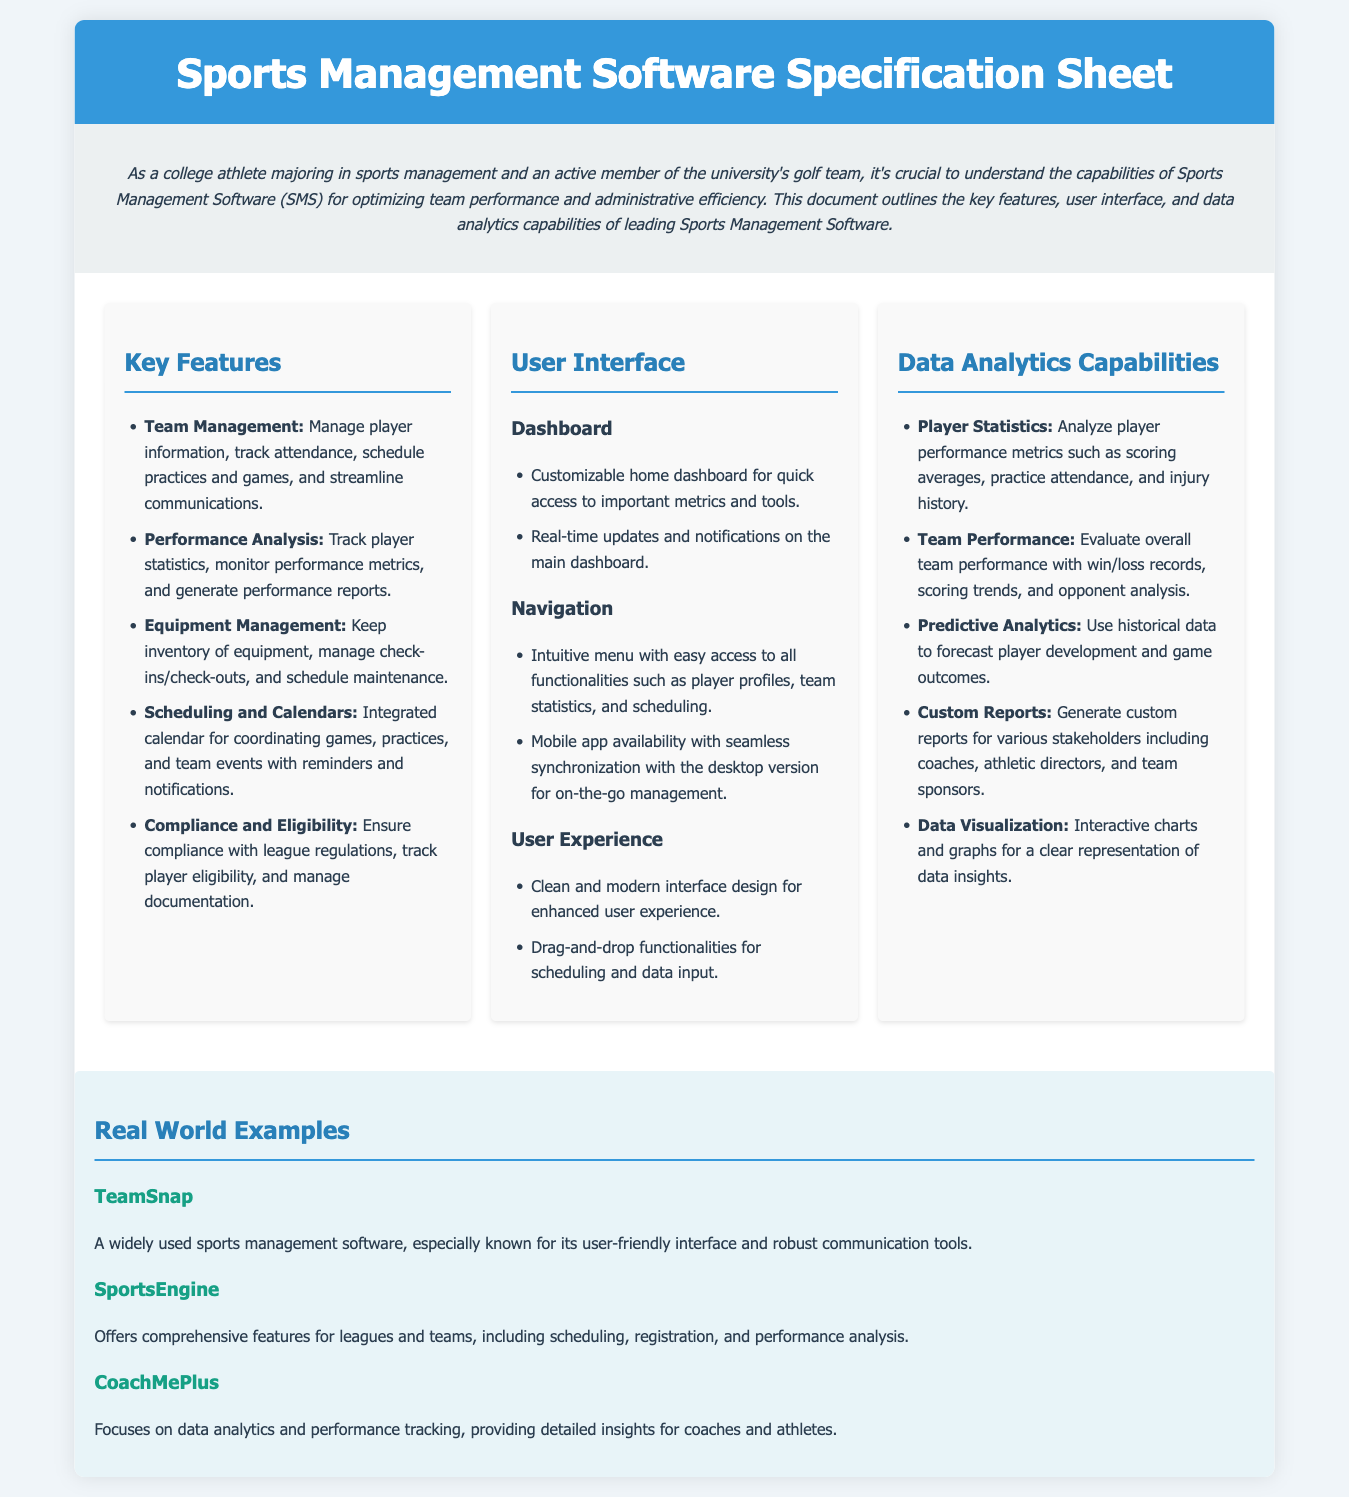What is the first key feature listed? The first key feature mentioned under Key Features is Team Management, which focuses on managing player information.
Answer: Team Management How many key features are listed? The document outlines five key features of the Sports Management Software.
Answer: Five What is a user interface feature related to notifications? The document states that real-time updates and notifications are available on the main dashboard.
Answer: Real-time updates Name one software mentioned as a real-world example. The document provides several examples, including TeamSnap, which is known for its user-friendly interface.
Answer: TeamSnap What type of analytics does the software offer to analyze player performance? The software includes analytics for Player Statistics to track performance metrics such as scoring averages.
Answer: Player Statistics How can the user experience be described in the document? The document describes the user experience as having a clean and modern interface design.
Answer: Clean and modern What is a predictive analytics capability mentioned? The document states that predictive analytics can be used to forecast player development and game outcomes based on historical data.
Answer: Forecast player development Which section of the document discusses data visualization? The section titled "Data Analytics Capabilities" discusses Data Visualization, highlighting interactive charts and graphs.
Answer: Data Analytics Capabilities What navigation feature is highlighted for mobile users? The document mentions mobile app availability with seamless synchronization with the desktop version for on-the-go management.
Answer: Mobile app availability 